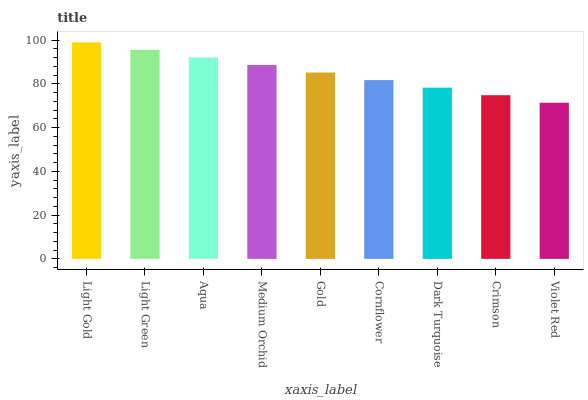Is Violet Red the minimum?
Answer yes or no. Yes. Is Light Gold the maximum?
Answer yes or no. Yes. Is Light Green the minimum?
Answer yes or no. No. Is Light Green the maximum?
Answer yes or no. No. Is Light Gold greater than Light Green?
Answer yes or no. Yes. Is Light Green less than Light Gold?
Answer yes or no. Yes. Is Light Green greater than Light Gold?
Answer yes or no. No. Is Light Gold less than Light Green?
Answer yes or no. No. Is Gold the high median?
Answer yes or no. Yes. Is Gold the low median?
Answer yes or no. Yes. Is Medium Orchid the high median?
Answer yes or no. No. Is Cornflower the low median?
Answer yes or no. No. 